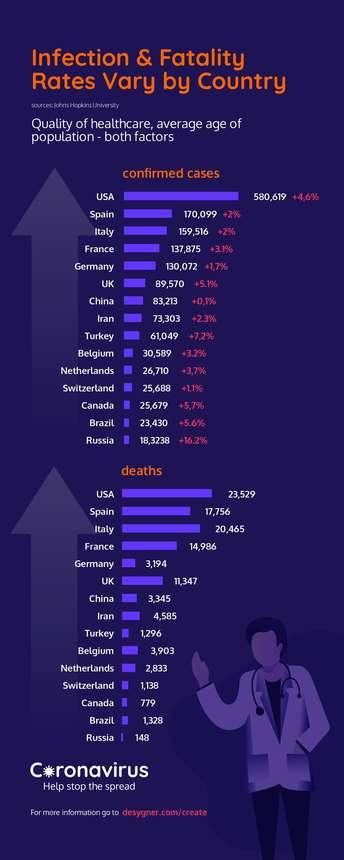Highlight a few significant elements in this photo. Russia has reported the lowest number of confirmed COVID-19 cases among all countries. There have been 25,679 confirmed cases of COVID-19 in Canada as of March 9, 2023. In Italy, there have been a total of 20,465 reported deaths from COVID-19. Russia has reported the lowest number of COVID-19 deaths among all countries. As of February 2022, the reported number of COVID-19 deaths in China is 3,345. 